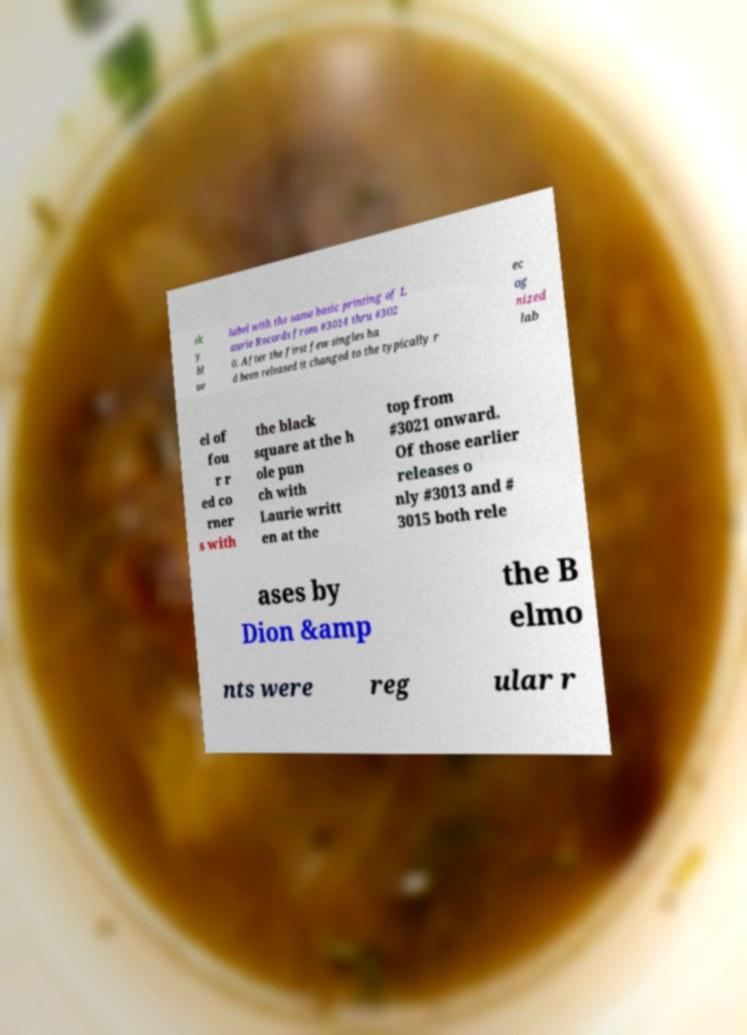There's text embedded in this image that I need extracted. Can you transcribe it verbatim? sk y bl ue label with the same basic printing of L aurie Records from #3014 thru #302 0. After the first few singles ha d been released it changed to the typically r ec og nized lab el of fou r r ed co rner s with the black square at the h ole pun ch with Laurie writt en at the top from #3021 onward. Of those earlier releases o nly #3013 and # 3015 both rele ases by Dion &amp the B elmo nts were reg ular r 